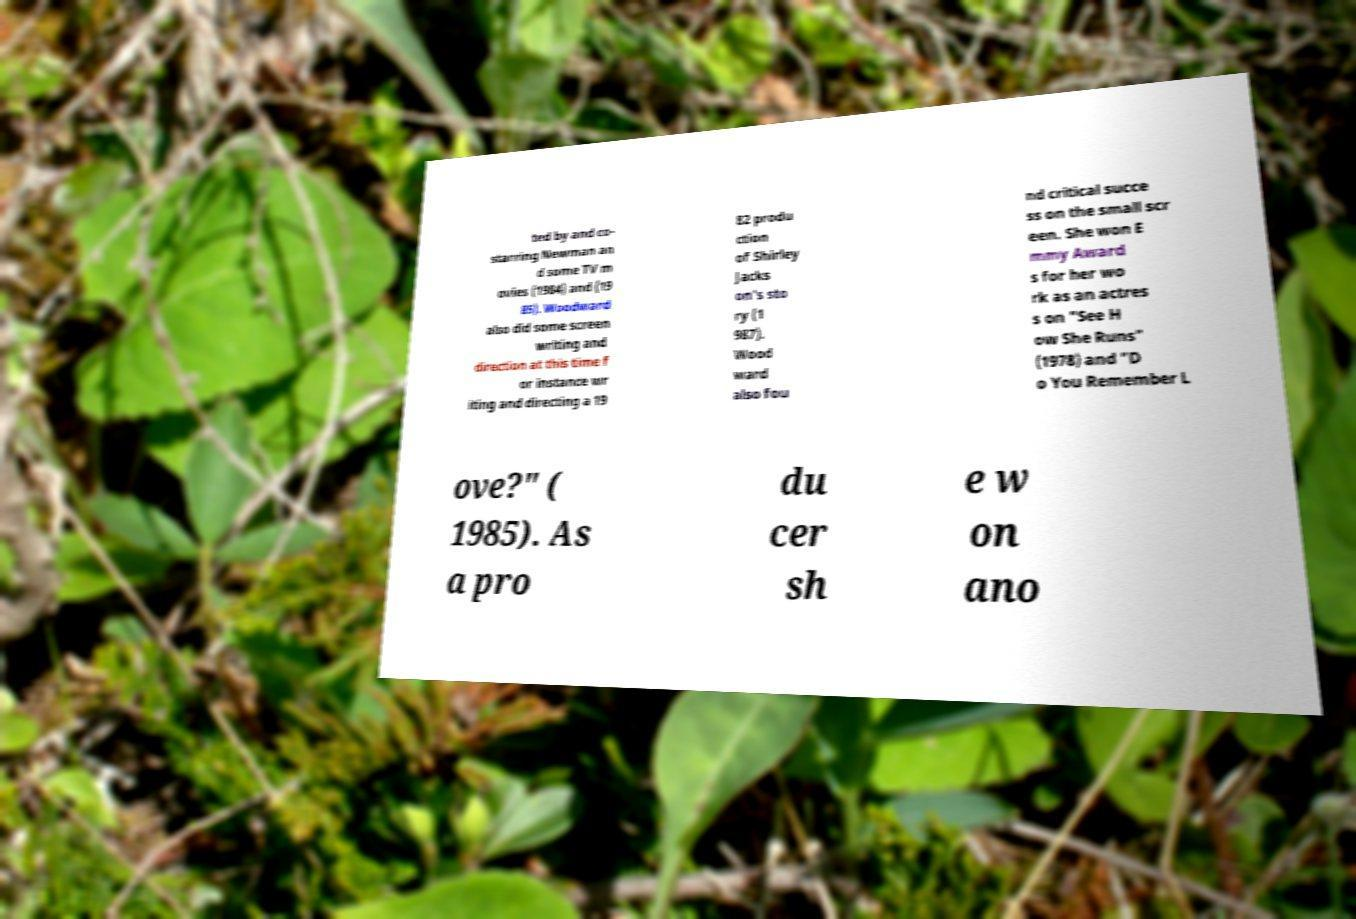Please identify and transcribe the text found in this image. ted by and co- starring Newman an d some TV m ovies (1984) and (19 85). Woodward also did some screen writing and direction at this time f or instance wr iting and directing a 19 82 produ ction of Shirley Jacks on's sto ry (1 987). Wood ward also fou nd critical succe ss on the small scr een. She won E mmy Award s for her wo rk as an actres s on "See H ow She Runs" (1978) and "D o You Remember L ove?" ( 1985). As a pro du cer sh e w on ano 